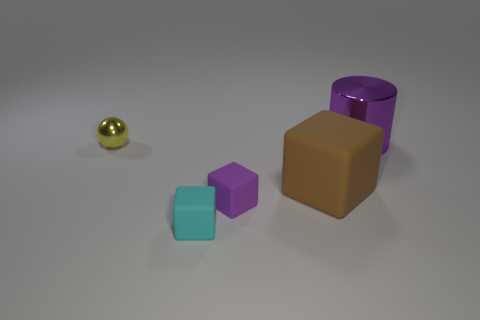Subtract all purple cubes. How many cubes are left? 2 Subtract all cubes. How many objects are left? 2 Subtract 2 cubes. How many cubes are left? 1 Subtract all cyan balls. How many brown blocks are left? 1 Subtract all purple rubber objects. Subtract all big cubes. How many objects are left? 3 Add 3 brown objects. How many brown objects are left? 4 Add 3 tiny gray cylinders. How many tiny gray cylinders exist? 3 Add 4 large brown matte things. How many objects exist? 9 Subtract all cyan cubes. How many cubes are left? 2 Subtract 0 red blocks. How many objects are left? 5 